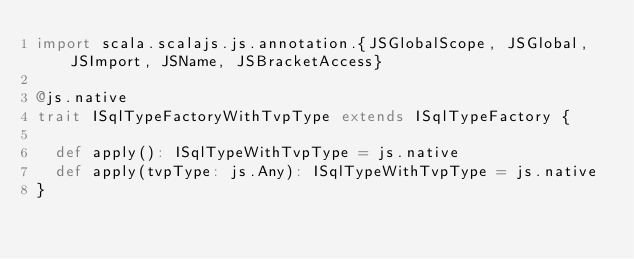<code> <loc_0><loc_0><loc_500><loc_500><_Scala_>import scala.scalajs.js.annotation.{JSGlobalScope, JSGlobal, JSImport, JSName, JSBracketAccess}

@js.native
trait ISqlTypeFactoryWithTvpType extends ISqlTypeFactory {
  
  def apply(): ISqlTypeWithTvpType = js.native
  def apply(tvpType: js.Any): ISqlTypeWithTvpType = js.native
}
</code> 